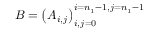Convert formula to latex. <formula><loc_0><loc_0><loc_500><loc_500>B = \left ( A _ { i , j } \right ) _ { i , j = 0 } ^ { i = n _ { 1 } - 1 , j = n _ { 1 } - 1 }</formula> 